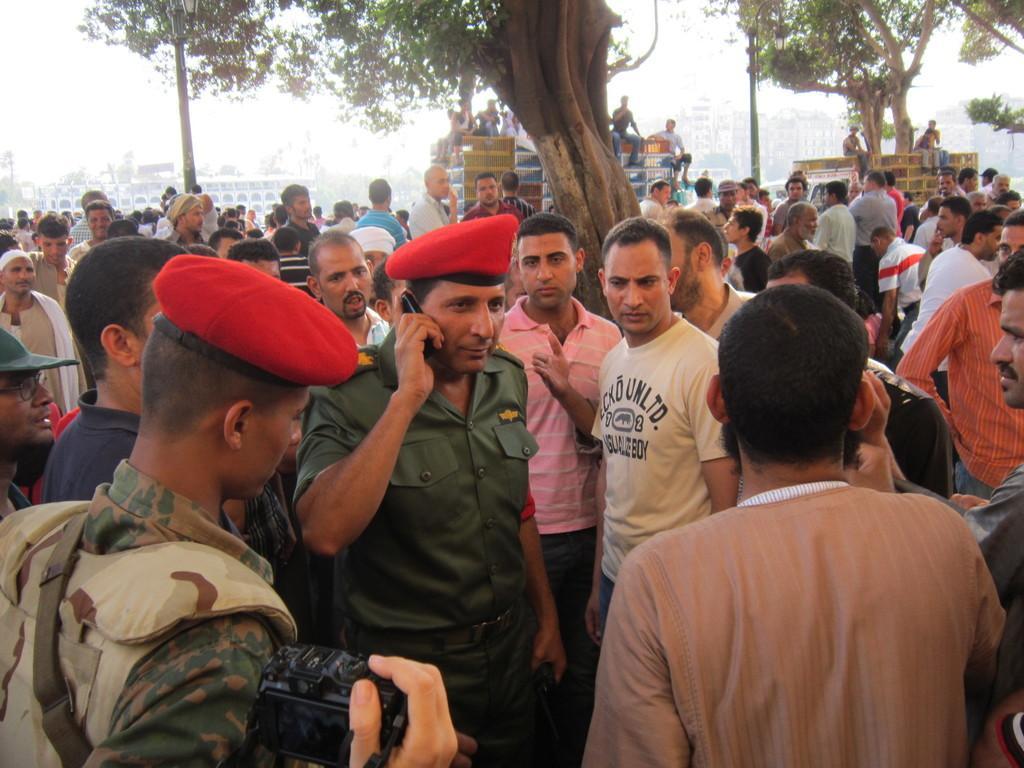In one or two sentences, can you explain what this image depicts? in this image there are group of people standing and few among them are wearing an army uniform, in the background there are a few trees and buildings. 